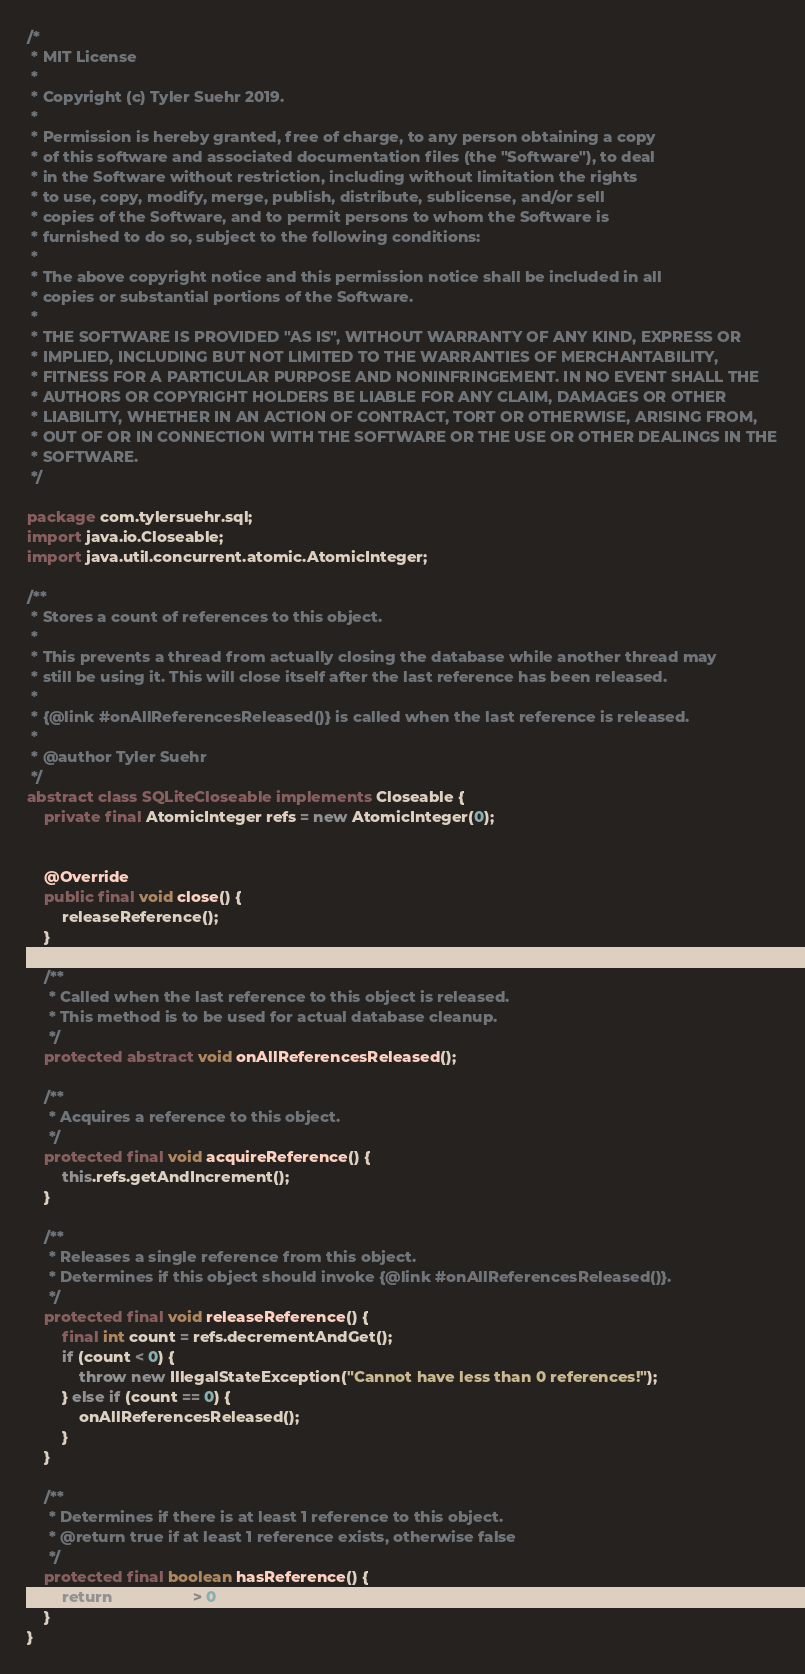Convert code to text. <code><loc_0><loc_0><loc_500><loc_500><_Java_>/*
 * MIT License
 *
 * Copyright (c) Tyler Suehr 2019.
 *
 * Permission is hereby granted, free of charge, to any person obtaining a copy
 * of this software and associated documentation files (the "Software"), to deal
 * in the Software without restriction, including without limitation the rights
 * to use, copy, modify, merge, publish, distribute, sublicense, and/or sell
 * copies of the Software, and to permit persons to whom the Software is
 * furnished to do so, subject to the following conditions:
 *
 * The above copyright notice and this permission notice shall be included in all
 * copies or substantial portions of the Software.
 *
 * THE SOFTWARE IS PROVIDED "AS IS", WITHOUT WARRANTY OF ANY KIND, EXPRESS OR
 * IMPLIED, INCLUDING BUT NOT LIMITED TO THE WARRANTIES OF MERCHANTABILITY,
 * FITNESS FOR A PARTICULAR PURPOSE AND NONINFRINGEMENT. IN NO EVENT SHALL THE
 * AUTHORS OR COPYRIGHT HOLDERS BE LIABLE FOR ANY CLAIM, DAMAGES OR OTHER
 * LIABILITY, WHETHER IN AN ACTION OF CONTRACT, TORT OR OTHERWISE, ARISING FROM,
 * OUT OF OR IN CONNECTION WITH THE SOFTWARE OR THE USE OR OTHER DEALINGS IN THE
 * SOFTWARE.
 */

package com.tylersuehr.sql;
import java.io.Closeable;
import java.util.concurrent.atomic.AtomicInteger;

/**
 * Stores a count of references to this object.
 *
 * This prevents a thread from actually closing the database while another thread may
 * still be using it. This will close itself after the last reference has been released.
 *
 * {@link #onAllReferencesReleased()} is called when the last reference is released.
 *
 * @author Tyler Suehr
 */
abstract class SQLiteCloseable implements Closeable {
    private final AtomicInteger refs = new AtomicInteger(0);


    @Override
    public final void close() {
        releaseReference();
    }

    /**
     * Called when the last reference to this object is released.
     * This method is to be used for actual database cleanup.
     */
    protected abstract void onAllReferencesReleased();

    /**
     * Acquires a reference to this object.
     */
    protected final void acquireReference() {
        this.refs.getAndIncrement();
    }

    /**
     * Releases a single reference from this object.
     * Determines if this object should invoke {@link #onAllReferencesReleased()}.
     */
    protected final void releaseReference() {
        final int count = refs.decrementAndGet();
        if (count < 0) {
            throw new IllegalStateException("Cannot have less than 0 references!");
        } else if (count == 0) {
            onAllReferencesReleased();
        }
    }

    /**
     * Determines if there is at least 1 reference to this object.
     * @return true if at least 1 reference exists, otherwise false
     */
    protected final boolean hasReference() {
        return refs.get() > 0;
    }
}</code> 